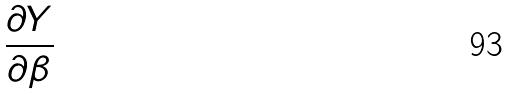Convert formula to latex. <formula><loc_0><loc_0><loc_500><loc_500>\frac { \partial Y } { \partial \beta }</formula> 